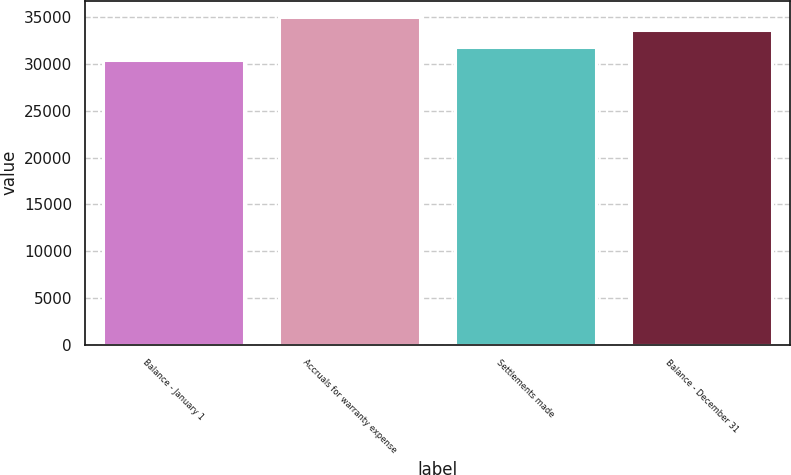<chart> <loc_0><loc_0><loc_500><loc_500><bar_chart><fcel>Balance - January 1<fcel>Accruals for warranty expense<fcel>Settlements made<fcel>Balance - December 31<nl><fcel>30459<fcel>35001<fcel>31859<fcel>33601<nl></chart> 